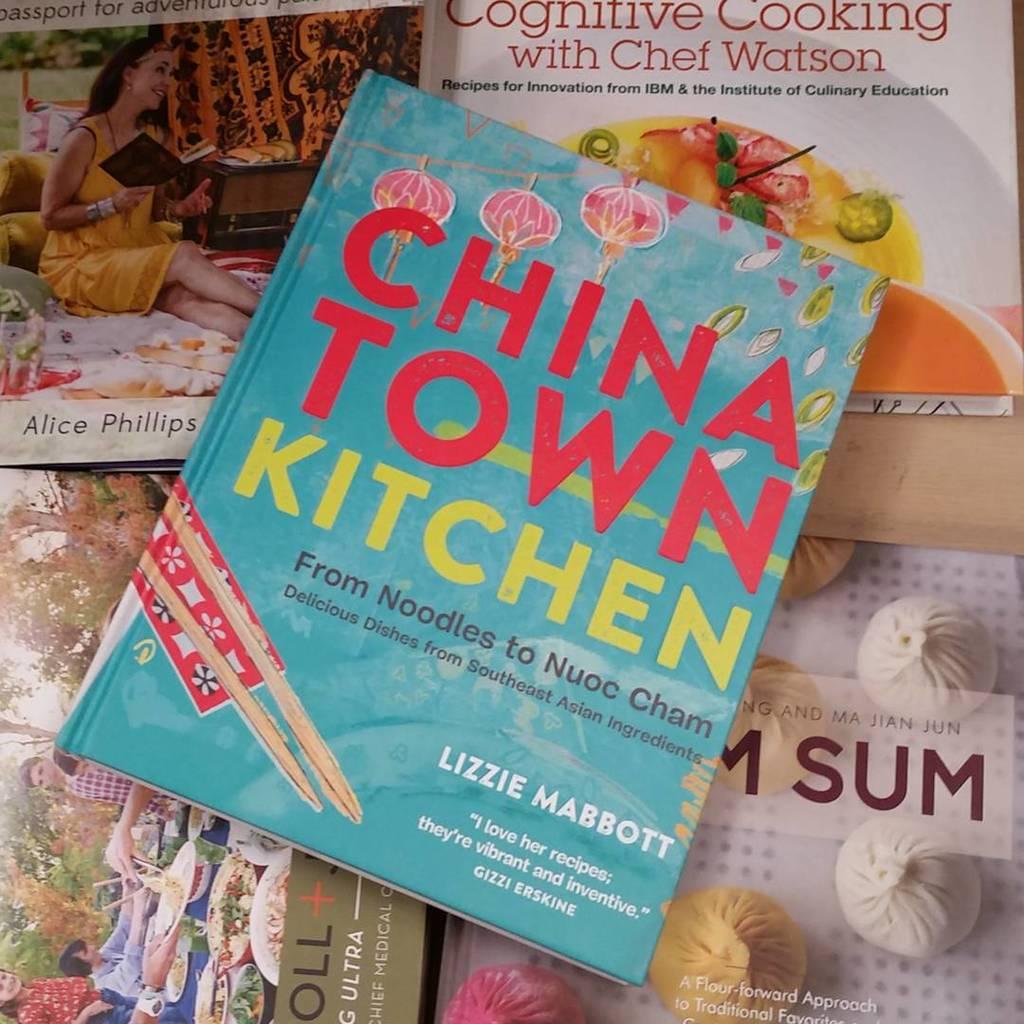<image>
Render a clear and concise summary of the photo. A book on top of other books that discuss Asian food. 